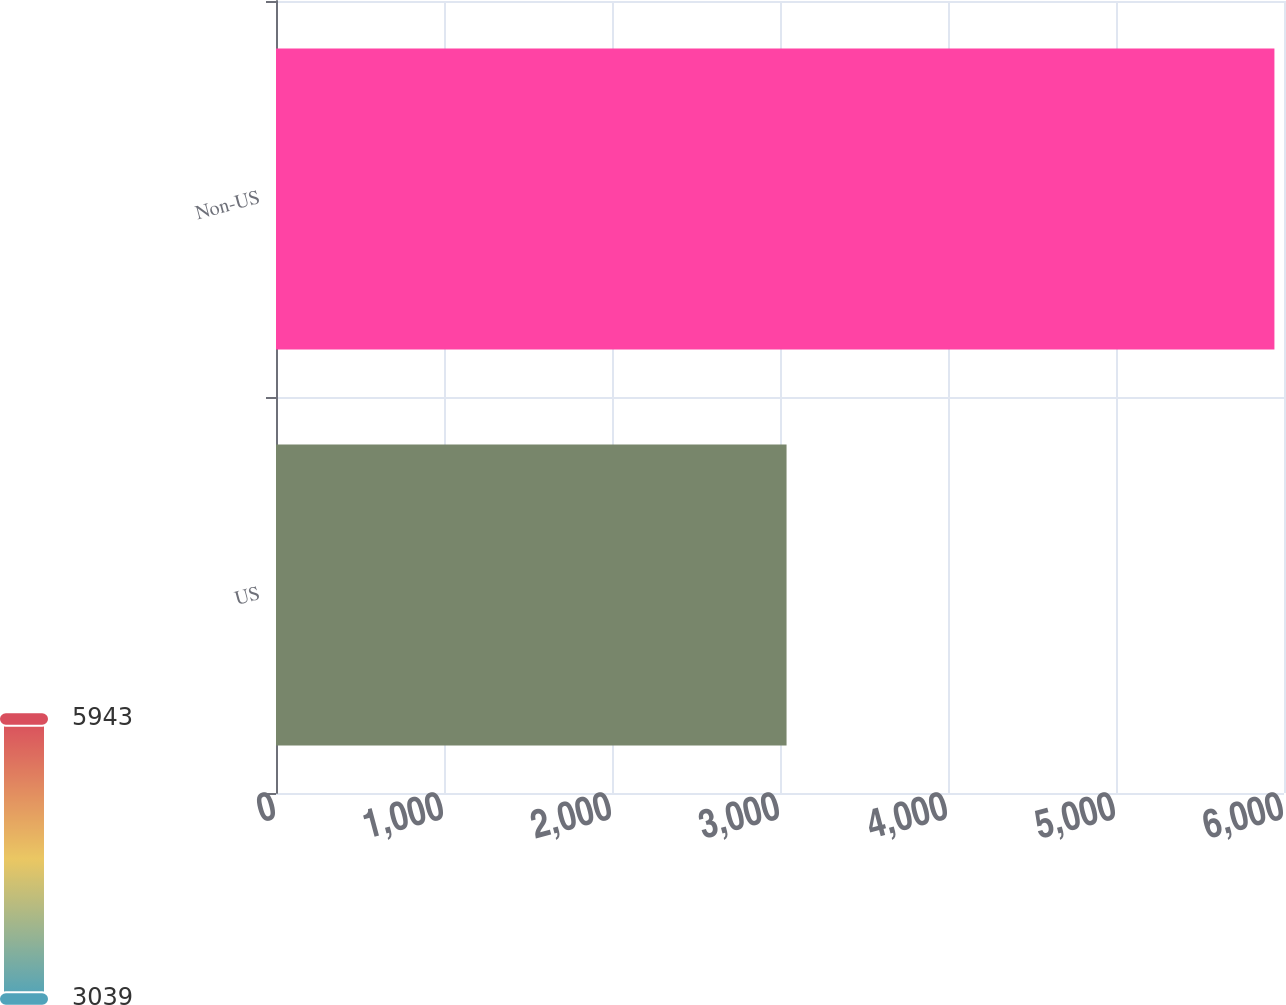<chart> <loc_0><loc_0><loc_500><loc_500><bar_chart><fcel>US<fcel>Non-US<nl><fcel>3039<fcel>5943<nl></chart> 